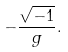Convert formula to latex. <formula><loc_0><loc_0><loc_500><loc_500>- \frac { \sqrt { - 1 } } { g } .</formula> 